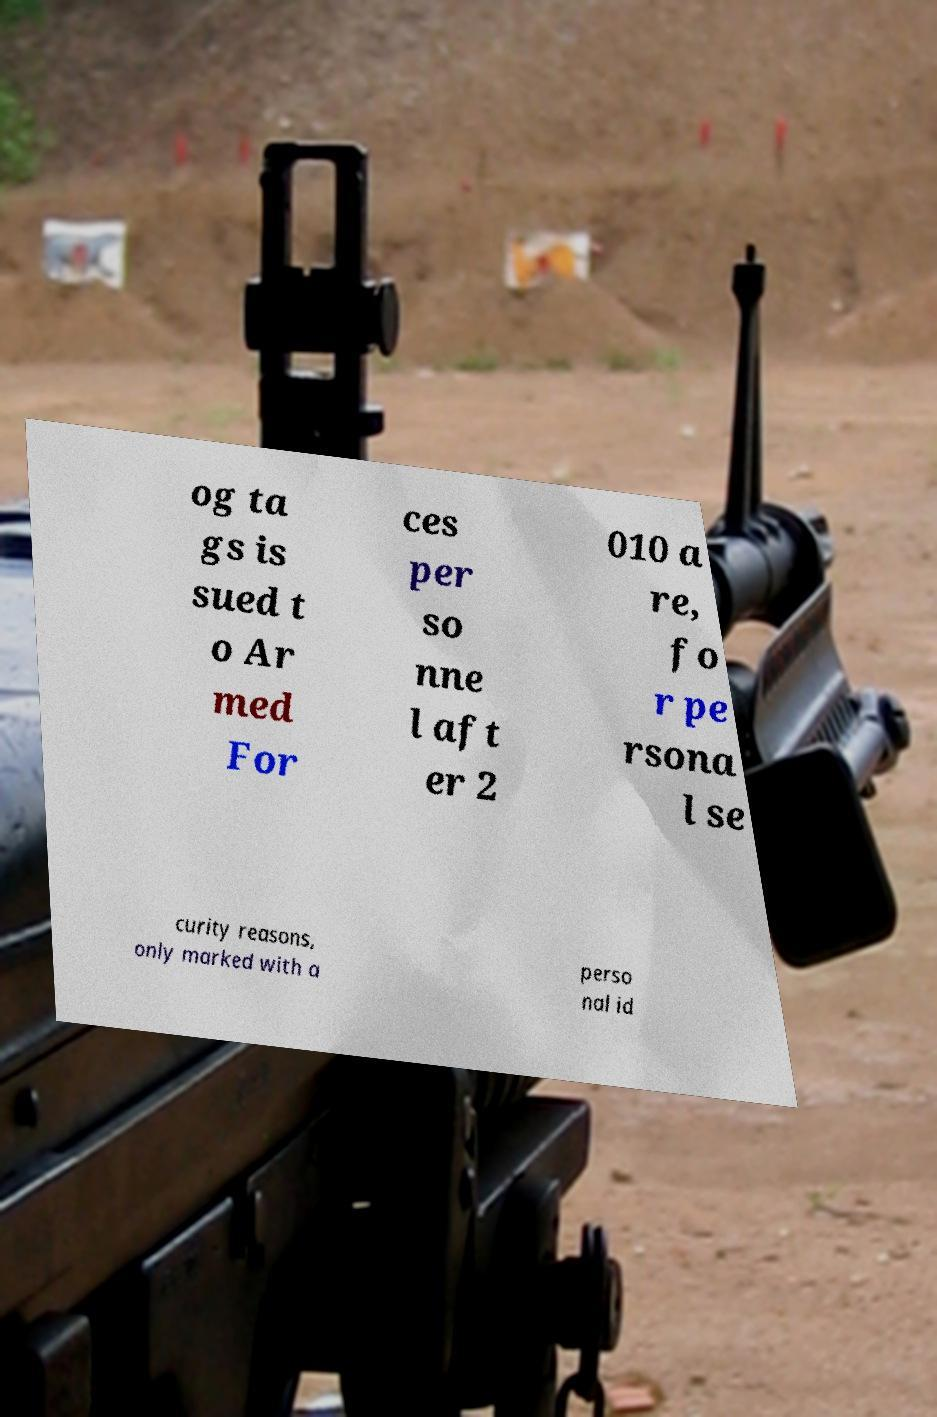What messages or text are displayed in this image? I need them in a readable, typed format. og ta gs is sued t o Ar med For ces per so nne l aft er 2 010 a re, fo r pe rsona l se curity reasons, only marked with a perso nal id 